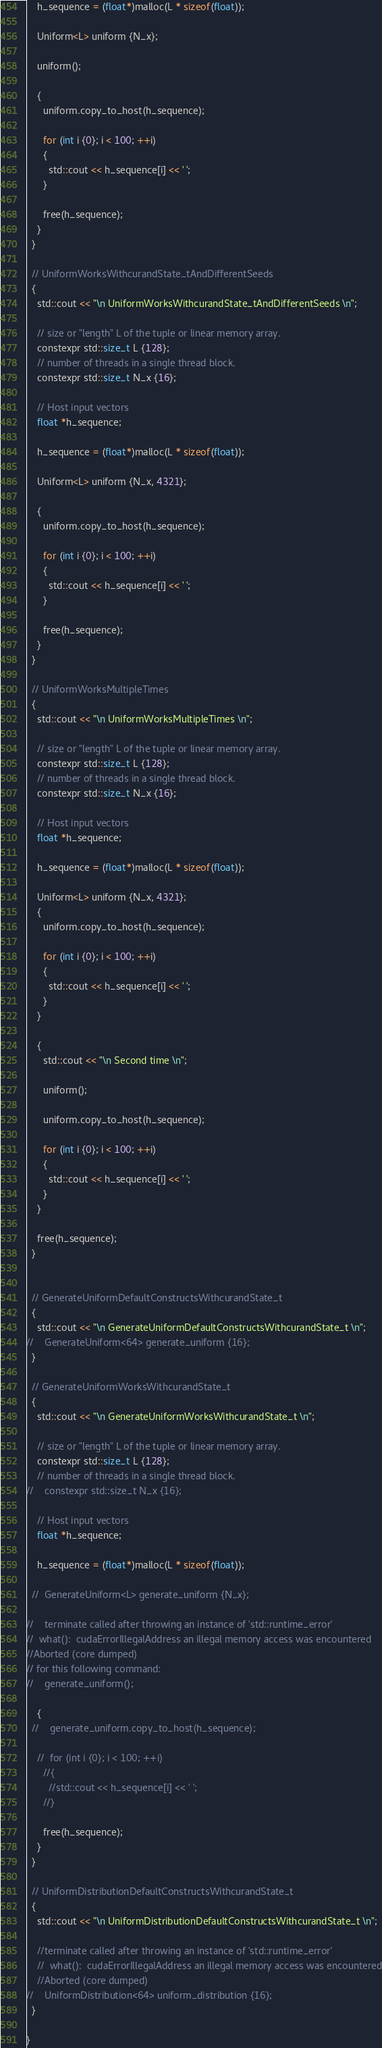Convert code to text. <code><loc_0><loc_0><loc_500><loc_500><_Cuda_>
    h_sequence = (float*)malloc(L * sizeof(float));

    Uniform<L> uniform {N_x};

    uniform();

    {
      uniform.copy_to_host(h_sequence);

      for (int i {0}; i < 100; ++i)
      {
        std::cout << h_sequence[i] << ' ';
      }

      free(h_sequence);
    }
  }

  // UniformWorksWithcurandState_tAndDifferentSeeds
  {
    std::cout << "\n UniformWorksWithcurandState_tAndDifferentSeeds \n";

    // size or "length" L of the tuple or linear memory array.
    constexpr std::size_t L {128};
    // number of threads in a single thread block.
    constexpr std::size_t N_x {16};

    // Host input vectors
    float *h_sequence;

    h_sequence = (float*)malloc(L * sizeof(float));

    Uniform<L> uniform {N_x, 4321};

    {
      uniform.copy_to_host(h_sequence);

      for (int i {0}; i < 100; ++i)
      {
        std::cout << h_sequence[i] << ' ';
      }

      free(h_sequence);
    }
  }

  // UniformWorksMultipleTimes
  {
    std::cout << "\n UniformWorksMultipleTimes \n";

    // size or "length" L of the tuple or linear memory array.
    constexpr std::size_t L {128};
    // number of threads in a single thread block.
    constexpr std::size_t N_x {16};

    // Host input vectors
    float *h_sequence;

    h_sequence = (float*)malloc(L * sizeof(float));

    Uniform<L> uniform {N_x, 4321};
    {
      uniform.copy_to_host(h_sequence);

      for (int i {0}; i < 100; ++i)
      {
        std::cout << h_sequence[i] << ' ';
      }
    }

    {
      std::cout << "\n Second time \n";

      uniform();

      uniform.copy_to_host(h_sequence);

      for (int i {0}; i < 100; ++i)
      {
        std::cout << h_sequence[i] << ' ';
      }  
    }

    free(h_sequence);
  }


  // GenerateUniformDefaultConstructsWithcurandState_t
  {
    std::cout << "\n GenerateUniformDefaultConstructsWithcurandState_t \n";
//    GenerateUniform<64> generate_uniform {16};
  }

  // GenerateUniformWorksWithcurandState_t
  {
    std::cout << "\n GenerateUniformWorksWithcurandState_t \n";

    // size or "length" L of the tuple or linear memory array.
    constexpr std::size_t L {128};
    // number of threads in a single thread block.
//    constexpr std::size_t N_x {16};

    // Host input vectors
    float *h_sequence;

    h_sequence = (float*)malloc(L * sizeof(float));

  //  GenerateUniform<L> generate_uniform {N_x};

//    terminate called after throwing an instance of 'std::runtime_error'
//  what():  cudaErrorIllegalAddress an illegal memory access was encountered
//Aborted (core dumped)
// for this following command:
//    generate_uniform();

    {
  //    generate_uniform.copy_to_host(h_sequence);

    //  for (int i {0}; i < 100; ++i)
      //{
        //std::cout << h_sequence[i] << ' ';
      //}

      free(h_sequence);
    }
  }

  // UniformDistributionDefaultConstructsWithcurandState_t
  {
    std::cout << "\n UniformDistributionDefaultConstructsWithcurandState_t \n";
 
    //terminate called after throwing an instance of 'std::runtime_error'
    //  what():  cudaErrorIllegalAddress an illegal memory access was encountered
    //Aborted (core dumped)
//    UniformDistribution<64> uniform_distribution {16};
  }

}</code> 